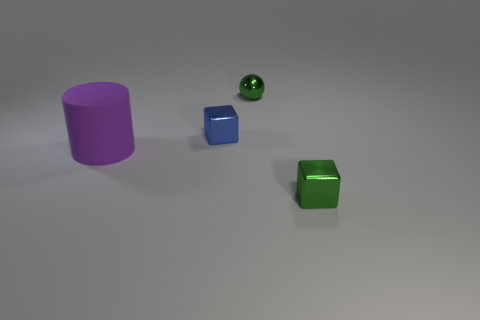Subtract 1 cubes. How many cubes are left? 1 Add 1 tiny blue objects. How many objects exist? 5 Subtract 0 cyan spheres. How many objects are left? 4 Subtract all yellow cylinders. Subtract all yellow spheres. How many cylinders are left? 1 Subtract all brown spheres. How many blue cubes are left? 1 Subtract all brown blocks. Subtract all purple objects. How many objects are left? 3 Add 3 small spheres. How many small spheres are left? 4 Add 4 purple rubber cylinders. How many purple rubber cylinders exist? 5 